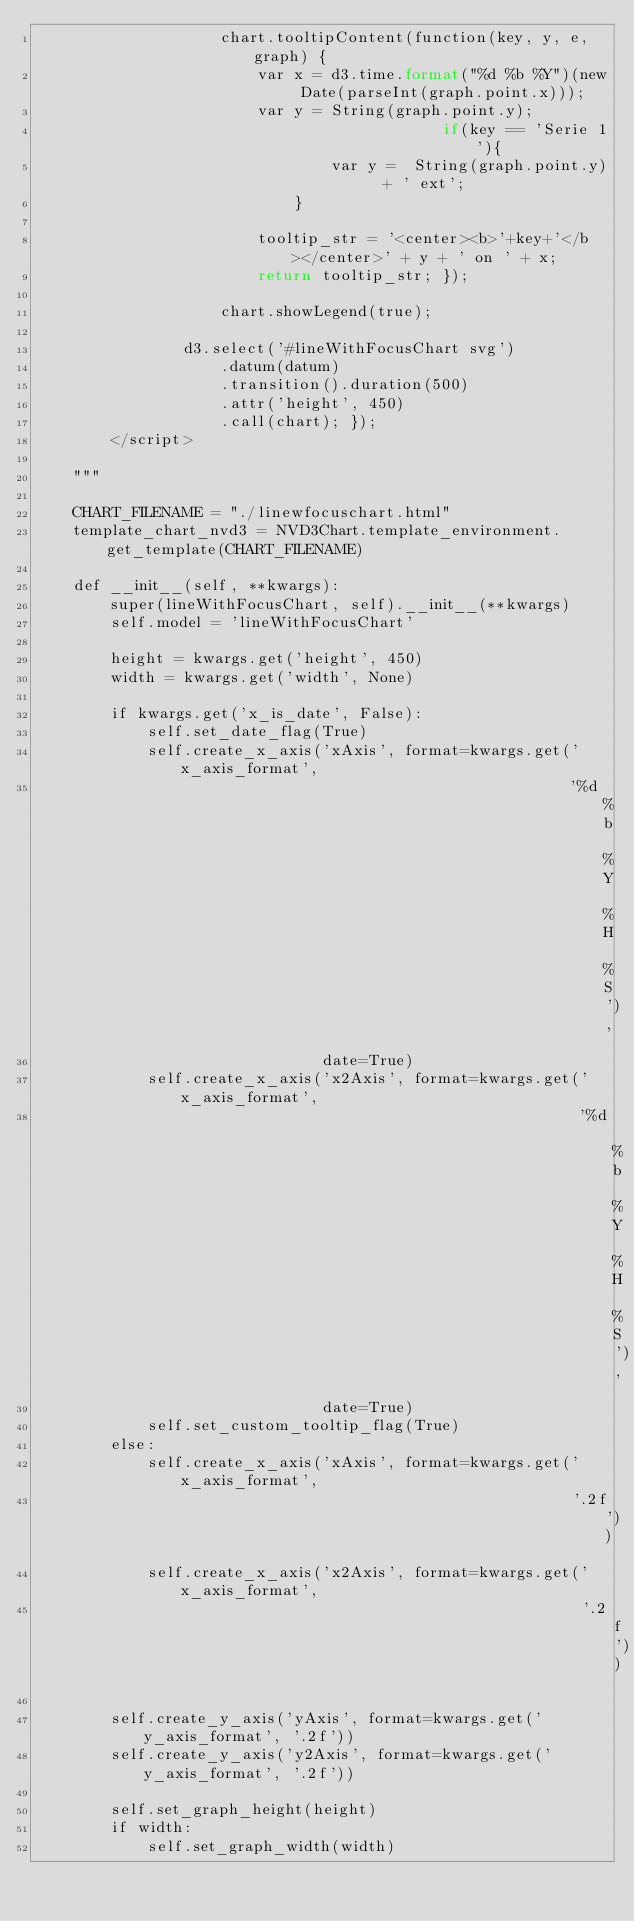Convert code to text. <code><loc_0><loc_0><loc_500><loc_500><_Python_>                    chart.tooltipContent(function(key, y, e, graph) {
                        var x = d3.time.format("%d %b %Y")(new Date(parseInt(graph.point.x)));
                        var y = String(graph.point.y);
                                            if(key == 'Serie 1'){
                                var y =  String(graph.point.y)  + ' ext';
                            }

                        tooltip_str = '<center><b>'+key+'</b></center>' + y + ' on ' + x;
                        return tooltip_str; });

                    chart.showLegend(true);

                d3.select('#lineWithFocusChart svg')
                    .datum(datum)
                    .transition().duration(500)
                    .attr('height', 450)
                    .call(chart); });
        </script>

    """

    CHART_FILENAME = "./linewfocuschart.html"
    template_chart_nvd3 = NVD3Chart.template_environment.get_template(CHART_FILENAME)

    def __init__(self, **kwargs):
        super(lineWithFocusChart, self).__init__(**kwargs)
        self.model = 'lineWithFocusChart'

        height = kwargs.get('height', 450)
        width = kwargs.get('width', None)

        if kwargs.get('x_is_date', False):
            self.set_date_flag(True)
            self.create_x_axis('xAxis', format=kwargs.get('x_axis_format',
                                                          '%d %b %Y %H %S'),
                               date=True)
            self.create_x_axis('x2Axis', format=kwargs.get('x_axis_format',
                                                           '%d %b %Y %H %S'),
                               date=True)
            self.set_custom_tooltip_flag(True)
        else:
            self.create_x_axis('xAxis', format=kwargs.get('x_axis_format',
                                                          '.2f'))
            self.create_x_axis('x2Axis', format=kwargs.get('x_axis_format',
                                                           '.2f'))

        self.create_y_axis('yAxis', format=kwargs.get('y_axis_format', '.2f'))
        self.create_y_axis('y2Axis', format=kwargs.get('y_axis_format', '.2f'))

        self.set_graph_height(height)
        if width:
            self.set_graph_width(width)
</code> 